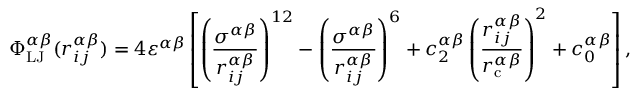<formula> <loc_0><loc_0><loc_500><loc_500>\Phi _ { L J } ^ { \alpha \beta } ( r _ { i j } ^ { \alpha \beta } ) = 4 \varepsilon ^ { \alpha \beta } \left [ \left ( \frac { \sigma ^ { \alpha \beta } } { r _ { i j } ^ { \alpha \beta } } \right ) ^ { 1 2 } - \left ( \frac { \sigma ^ { \alpha \beta } } { r _ { i j } ^ { \alpha \beta } } \right ) ^ { 6 } + c _ { 2 } ^ { \alpha \beta } \left ( \frac { r _ { i j } ^ { \alpha \beta } } { r _ { c } ^ { \alpha \beta } } \right ) ^ { 2 } + c _ { 0 } ^ { \alpha \beta } \right ] ,</formula> 